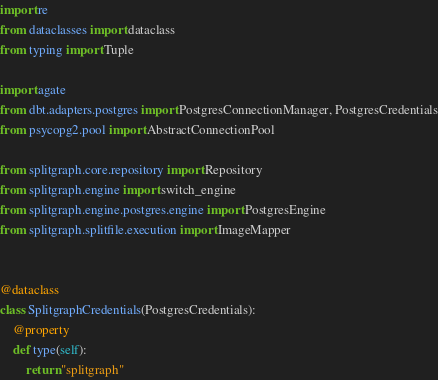Convert code to text. <code><loc_0><loc_0><loc_500><loc_500><_Python_>import re
from dataclasses import dataclass
from typing import Tuple

import agate
from dbt.adapters.postgres import PostgresConnectionManager, PostgresCredentials
from psycopg2.pool import AbstractConnectionPool

from splitgraph.core.repository import Repository
from splitgraph.engine import switch_engine
from splitgraph.engine.postgres.engine import PostgresEngine
from splitgraph.splitfile.execution import ImageMapper


@dataclass
class SplitgraphCredentials(PostgresCredentials):
    @property
    def type(self):
        return "splitgraph"

</code> 